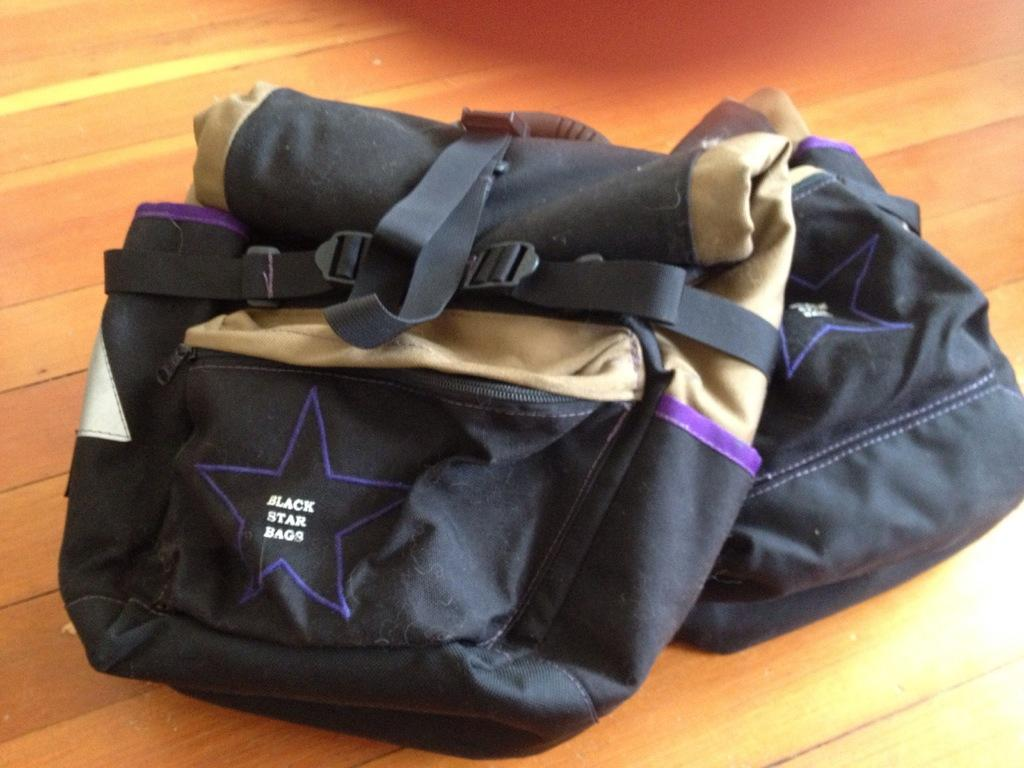How many bags can be seen in the image? There are two bags in the image. What is the color of one of the bags? One bag is black in color. What is the color of the other bag? The other bag is cream in color. On what type of surface are the bags placed? The bags are kept on a wooden floor. What type of wing is visible on the bags in the image? There are no wings visible on the bags in the image. What type of cloth is used to make the bags? The provided facts do not mention the type of cloth used to make the bags. 